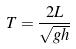Convert formula to latex. <formula><loc_0><loc_0><loc_500><loc_500>T = \frac { 2 L } { \sqrt { g h } }</formula> 